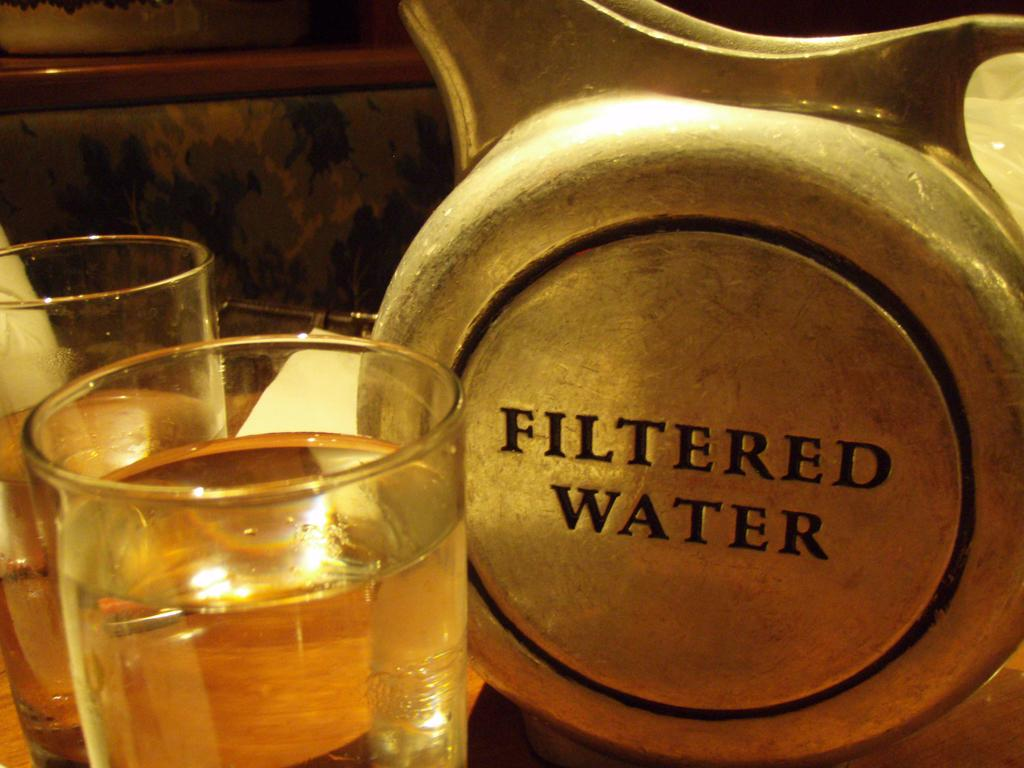<image>
Summarize the visual content of the image. Metal container with the words "Filtered Water" next to cups of water. 